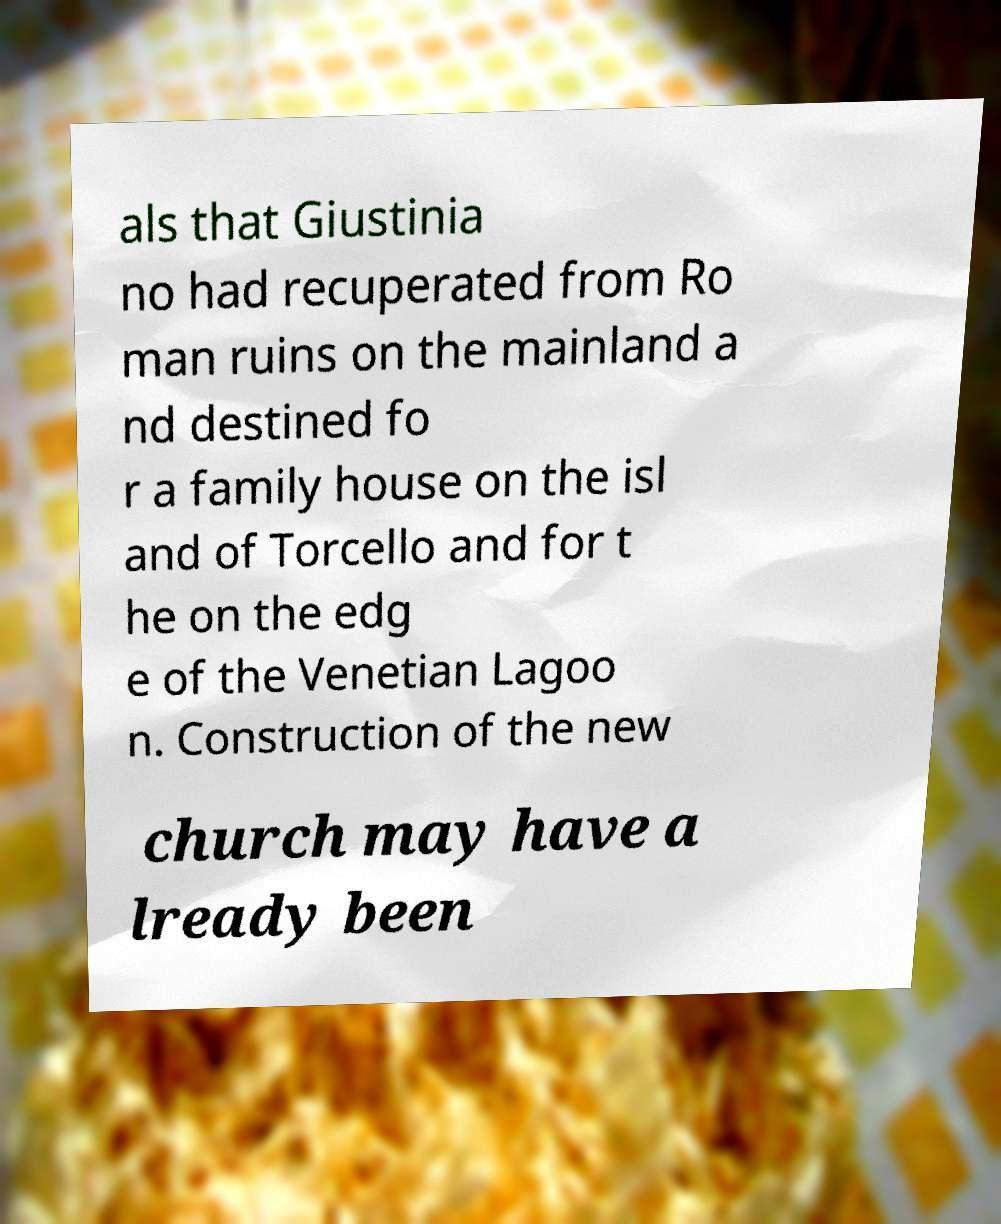There's text embedded in this image that I need extracted. Can you transcribe it verbatim? als that Giustinia no had recuperated from Ro man ruins on the mainland a nd destined fo r a family house on the isl and of Torcello and for t he on the edg e of the Venetian Lagoo n. Construction of the new church may have a lready been 